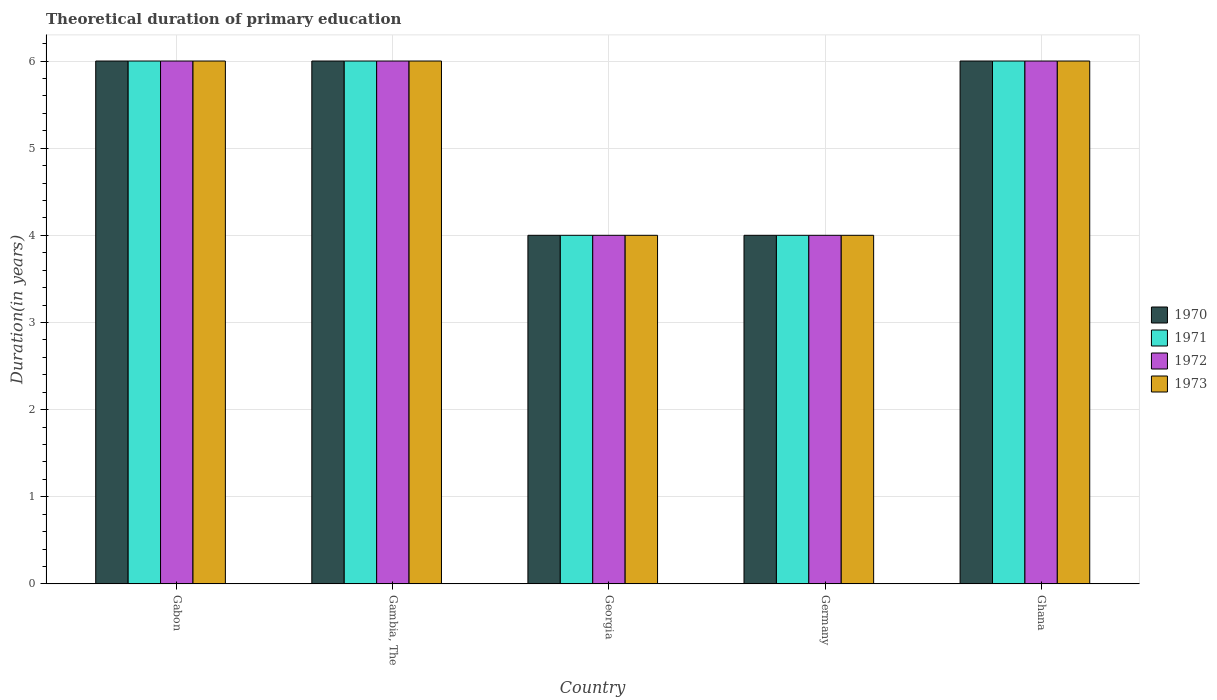How many groups of bars are there?
Ensure brevity in your answer.  5. How many bars are there on the 3rd tick from the left?
Your response must be concise. 4. What is the label of the 4th group of bars from the left?
Ensure brevity in your answer.  Germany. What is the total theoretical duration of primary education in 1972 in Georgia?
Make the answer very short. 4. Across all countries, what is the maximum total theoretical duration of primary education in 1970?
Provide a short and direct response. 6. Across all countries, what is the minimum total theoretical duration of primary education in 1971?
Your answer should be very brief. 4. In which country was the total theoretical duration of primary education in 1973 maximum?
Offer a very short reply. Gabon. In which country was the total theoretical duration of primary education in 1972 minimum?
Keep it short and to the point. Georgia. What is the average total theoretical duration of primary education in 1973 per country?
Offer a terse response. 5.2. In how many countries, is the total theoretical duration of primary education in 1971 greater than 3.6 years?
Ensure brevity in your answer.  5. What is the ratio of the total theoretical duration of primary education in 1973 in Georgia to that in Germany?
Offer a terse response. 1. Is the total theoretical duration of primary education in 1973 in Gabon less than that in Georgia?
Make the answer very short. No. What is the difference between the highest and the lowest total theoretical duration of primary education in 1970?
Ensure brevity in your answer.  2. Are all the bars in the graph horizontal?
Give a very brief answer. No. Where does the legend appear in the graph?
Give a very brief answer. Center right. How are the legend labels stacked?
Offer a terse response. Vertical. What is the title of the graph?
Make the answer very short. Theoretical duration of primary education. Does "1982" appear as one of the legend labels in the graph?
Provide a succinct answer. No. What is the label or title of the X-axis?
Offer a very short reply. Country. What is the label or title of the Y-axis?
Keep it short and to the point. Duration(in years). What is the Duration(in years) in 1970 in Gabon?
Your response must be concise. 6. What is the Duration(in years) of 1971 in Gabon?
Offer a terse response. 6. What is the Duration(in years) in 1973 in Gabon?
Your answer should be very brief. 6. What is the Duration(in years) in 1970 in Gambia, The?
Your answer should be very brief. 6. What is the Duration(in years) in 1970 in Georgia?
Your answer should be compact. 4. What is the Duration(in years) in 1971 in Georgia?
Offer a very short reply. 4. What is the Duration(in years) of 1970 in Germany?
Make the answer very short. 4. What is the Duration(in years) in 1972 in Germany?
Give a very brief answer. 4. What is the Duration(in years) of 1971 in Ghana?
Make the answer very short. 6. What is the Duration(in years) of 1972 in Ghana?
Your answer should be very brief. 6. Across all countries, what is the maximum Duration(in years) of 1971?
Provide a short and direct response. 6. Across all countries, what is the maximum Duration(in years) in 1973?
Keep it short and to the point. 6. Across all countries, what is the minimum Duration(in years) of 1970?
Ensure brevity in your answer.  4. Across all countries, what is the minimum Duration(in years) of 1971?
Ensure brevity in your answer.  4. Across all countries, what is the minimum Duration(in years) of 1973?
Offer a terse response. 4. What is the total Duration(in years) in 1970 in the graph?
Ensure brevity in your answer.  26. What is the total Duration(in years) in 1972 in the graph?
Give a very brief answer. 26. What is the total Duration(in years) of 1973 in the graph?
Ensure brevity in your answer.  26. What is the difference between the Duration(in years) of 1971 in Gabon and that in Gambia, The?
Your answer should be compact. 0. What is the difference between the Duration(in years) of 1972 in Gabon and that in Gambia, The?
Provide a succinct answer. 0. What is the difference between the Duration(in years) of 1970 in Gabon and that in Georgia?
Offer a terse response. 2. What is the difference between the Duration(in years) of 1971 in Gabon and that in Georgia?
Your answer should be compact. 2. What is the difference between the Duration(in years) in 1972 in Gabon and that in Georgia?
Provide a short and direct response. 2. What is the difference between the Duration(in years) of 1970 in Gabon and that in Germany?
Your answer should be compact. 2. What is the difference between the Duration(in years) in 1972 in Gambia, The and that in Georgia?
Your answer should be compact. 2. What is the difference between the Duration(in years) in 1970 in Gambia, The and that in Germany?
Your response must be concise. 2. What is the difference between the Duration(in years) in 1972 in Gambia, The and that in Germany?
Offer a very short reply. 2. What is the difference between the Duration(in years) of 1971 in Gambia, The and that in Ghana?
Your answer should be very brief. 0. What is the difference between the Duration(in years) in 1970 in Georgia and that in Germany?
Provide a short and direct response. 0. What is the difference between the Duration(in years) in 1971 in Georgia and that in Germany?
Your answer should be compact. 0. What is the difference between the Duration(in years) in 1972 in Georgia and that in Germany?
Your answer should be compact. 0. What is the difference between the Duration(in years) of 1970 in Georgia and that in Ghana?
Offer a terse response. -2. What is the difference between the Duration(in years) of 1971 in Germany and that in Ghana?
Your answer should be very brief. -2. What is the difference between the Duration(in years) of 1972 in Germany and that in Ghana?
Offer a terse response. -2. What is the difference between the Duration(in years) of 1973 in Germany and that in Ghana?
Ensure brevity in your answer.  -2. What is the difference between the Duration(in years) in 1971 in Gabon and the Duration(in years) in 1973 in Gambia, The?
Ensure brevity in your answer.  0. What is the difference between the Duration(in years) of 1970 in Gabon and the Duration(in years) of 1971 in Georgia?
Provide a short and direct response. 2. What is the difference between the Duration(in years) in 1971 in Gabon and the Duration(in years) in 1972 in Georgia?
Your response must be concise. 2. What is the difference between the Duration(in years) in 1971 in Gabon and the Duration(in years) in 1973 in Georgia?
Offer a terse response. 2. What is the difference between the Duration(in years) of 1972 in Gabon and the Duration(in years) of 1973 in Georgia?
Your answer should be compact. 2. What is the difference between the Duration(in years) in 1970 in Gabon and the Duration(in years) in 1971 in Germany?
Give a very brief answer. 2. What is the difference between the Duration(in years) in 1970 in Gabon and the Duration(in years) in 1972 in Germany?
Your answer should be very brief. 2. What is the difference between the Duration(in years) in 1971 in Gabon and the Duration(in years) in 1972 in Germany?
Make the answer very short. 2. What is the difference between the Duration(in years) in 1970 in Gabon and the Duration(in years) in 1973 in Ghana?
Ensure brevity in your answer.  0. What is the difference between the Duration(in years) in 1971 in Gabon and the Duration(in years) in 1973 in Ghana?
Provide a succinct answer. 0. What is the difference between the Duration(in years) in 1970 in Gambia, The and the Duration(in years) in 1971 in Georgia?
Your response must be concise. 2. What is the difference between the Duration(in years) in 1970 in Gambia, The and the Duration(in years) in 1972 in Georgia?
Your answer should be compact. 2. What is the difference between the Duration(in years) in 1970 in Gambia, The and the Duration(in years) in 1971 in Ghana?
Provide a short and direct response. 0. What is the difference between the Duration(in years) in 1971 in Gambia, The and the Duration(in years) in 1972 in Ghana?
Make the answer very short. 0. What is the difference between the Duration(in years) in 1971 in Gambia, The and the Duration(in years) in 1973 in Ghana?
Your answer should be compact. 0. What is the difference between the Duration(in years) of 1970 in Georgia and the Duration(in years) of 1972 in Germany?
Ensure brevity in your answer.  0. What is the difference between the Duration(in years) of 1971 in Georgia and the Duration(in years) of 1972 in Germany?
Keep it short and to the point. 0. What is the difference between the Duration(in years) in 1971 in Georgia and the Duration(in years) in 1973 in Germany?
Offer a very short reply. 0. What is the difference between the Duration(in years) of 1970 in Georgia and the Duration(in years) of 1973 in Ghana?
Offer a very short reply. -2. What is the difference between the Duration(in years) of 1972 in Georgia and the Duration(in years) of 1973 in Ghana?
Ensure brevity in your answer.  -2. What is the difference between the Duration(in years) of 1970 in Germany and the Duration(in years) of 1971 in Ghana?
Offer a very short reply. -2. What is the difference between the Duration(in years) in 1970 in Germany and the Duration(in years) in 1972 in Ghana?
Provide a succinct answer. -2. What is the difference between the Duration(in years) of 1971 in Germany and the Duration(in years) of 1972 in Ghana?
Your response must be concise. -2. What is the average Duration(in years) in 1970 per country?
Your answer should be very brief. 5.2. What is the difference between the Duration(in years) in 1970 and Duration(in years) in 1973 in Gabon?
Your response must be concise. 0. What is the difference between the Duration(in years) in 1970 and Duration(in years) in 1972 in Gambia, The?
Provide a succinct answer. 0. What is the difference between the Duration(in years) of 1970 and Duration(in years) of 1972 in Georgia?
Provide a short and direct response. 0. What is the difference between the Duration(in years) of 1971 and Duration(in years) of 1972 in Georgia?
Offer a very short reply. 0. What is the difference between the Duration(in years) in 1971 and Duration(in years) in 1973 in Georgia?
Provide a short and direct response. 0. What is the difference between the Duration(in years) of 1970 and Duration(in years) of 1972 in Germany?
Offer a very short reply. 0. What is the difference between the Duration(in years) in 1970 and Duration(in years) in 1973 in Germany?
Your answer should be compact. 0. What is the difference between the Duration(in years) of 1971 and Duration(in years) of 1972 in Germany?
Offer a very short reply. 0. What is the difference between the Duration(in years) in 1971 and Duration(in years) in 1973 in Germany?
Provide a succinct answer. 0. What is the difference between the Duration(in years) of 1972 and Duration(in years) of 1973 in Germany?
Your answer should be compact. 0. What is the difference between the Duration(in years) of 1970 and Duration(in years) of 1973 in Ghana?
Give a very brief answer. 0. What is the difference between the Duration(in years) in 1971 and Duration(in years) in 1973 in Ghana?
Provide a succinct answer. 0. What is the difference between the Duration(in years) in 1972 and Duration(in years) in 1973 in Ghana?
Ensure brevity in your answer.  0. What is the ratio of the Duration(in years) of 1970 in Gabon to that in Gambia, The?
Offer a terse response. 1. What is the ratio of the Duration(in years) of 1972 in Gabon to that in Gambia, The?
Your answer should be very brief. 1. What is the ratio of the Duration(in years) in 1970 in Gabon to that in Georgia?
Your answer should be compact. 1.5. What is the ratio of the Duration(in years) of 1971 in Gabon to that in Georgia?
Your answer should be compact. 1.5. What is the ratio of the Duration(in years) in 1972 in Gabon to that in Georgia?
Make the answer very short. 1.5. What is the ratio of the Duration(in years) of 1970 in Gabon to that in Germany?
Provide a short and direct response. 1.5. What is the ratio of the Duration(in years) in 1973 in Gabon to that in Germany?
Keep it short and to the point. 1.5. What is the ratio of the Duration(in years) of 1971 in Gabon to that in Ghana?
Give a very brief answer. 1. What is the ratio of the Duration(in years) in 1972 in Gabon to that in Ghana?
Offer a very short reply. 1. What is the ratio of the Duration(in years) of 1973 in Gabon to that in Ghana?
Offer a terse response. 1. What is the ratio of the Duration(in years) in 1971 in Gambia, The to that in Georgia?
Keep it short and to the point. 1.5. What is the ratio of the Duration(in years) in 1973 in Gambia, The to that in Georgia?
Ensure brevity in your answer.  1.5. What is the ratio of the Duration(in years) in 1970 in Gambia, The to that in Ghana?
Provide a succinct answer. 1. What is the ratio of the Duration(in years) of 1972 in Gambia, The to that in Ghana?
Your answer should be compact. 1. What is the ratio of the Duration(in years) in 1970 in Georgia to that in Germany?
Provide a short and direct response. 1. What is the ratio of the Duration(in years) in 1973 in Georgia to that in Germany?
Your answer should be compact. 1. What is the ratio of the Duration(in years) of 1970 in Georgia to that in Ghana?
Ensure brevity in your answer.  0.67. What is the ratio of the Duration(in years) of 1971 in Georgia to that in Ghana?
Keep it short and to the point. 0.67. What is the ratio of the Duration(in years) of 1973 in Georgia to that in Ghana?
Keep it short and to the point. 0.67. What is the ratio of the Duration(in years) of 1970 in Germany to that in Ghana?
Your answer should be compact. 0.67. What is the ratio of the Duration(in years) of 1972 in Germany to that in Ghana?
Make the answer very short. 0.67. What is the difference between the highest and the second highest Duration(in years) of 1973?
Offer a very short reply. 0. What is the difference between the highest and the lowest Duration(in years) in 1972?
Ensure brevity in your answer.  2. 